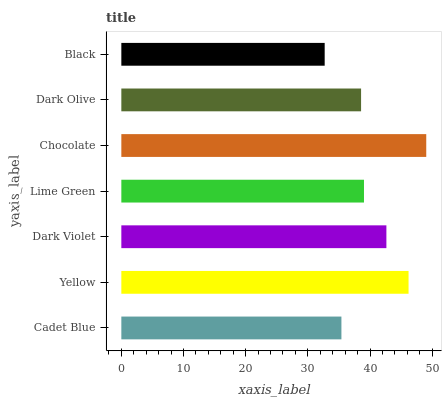Is Black the minimum?
Answer yes or no. Yes. Is Chocolate the maximum?
Answer yes or no. Yes. Is Yellow the minimum?
Answer yes or no. No. Is Yellow the maximum?
Answer yes or no. No. Is Yellow greater than Cadet Blue?
Answer yes or no. Yes. Is Cadet Blue less than Yellow?
Answer yes or no. Yes. Is Cadet Blue greater than Yellow?
Answer yes or no. No. Is Yellow less than Cadet Blue?
Answer yes or no. No. Is Lime Green the high median?
Answer yes or no. Yes. Is Lime Green the low median?
Answer yes or no. Yes. Is Dark Olive the high median?
Answer yes or no. No. Is Chocolate the low median?
Answer yes or no. No. 